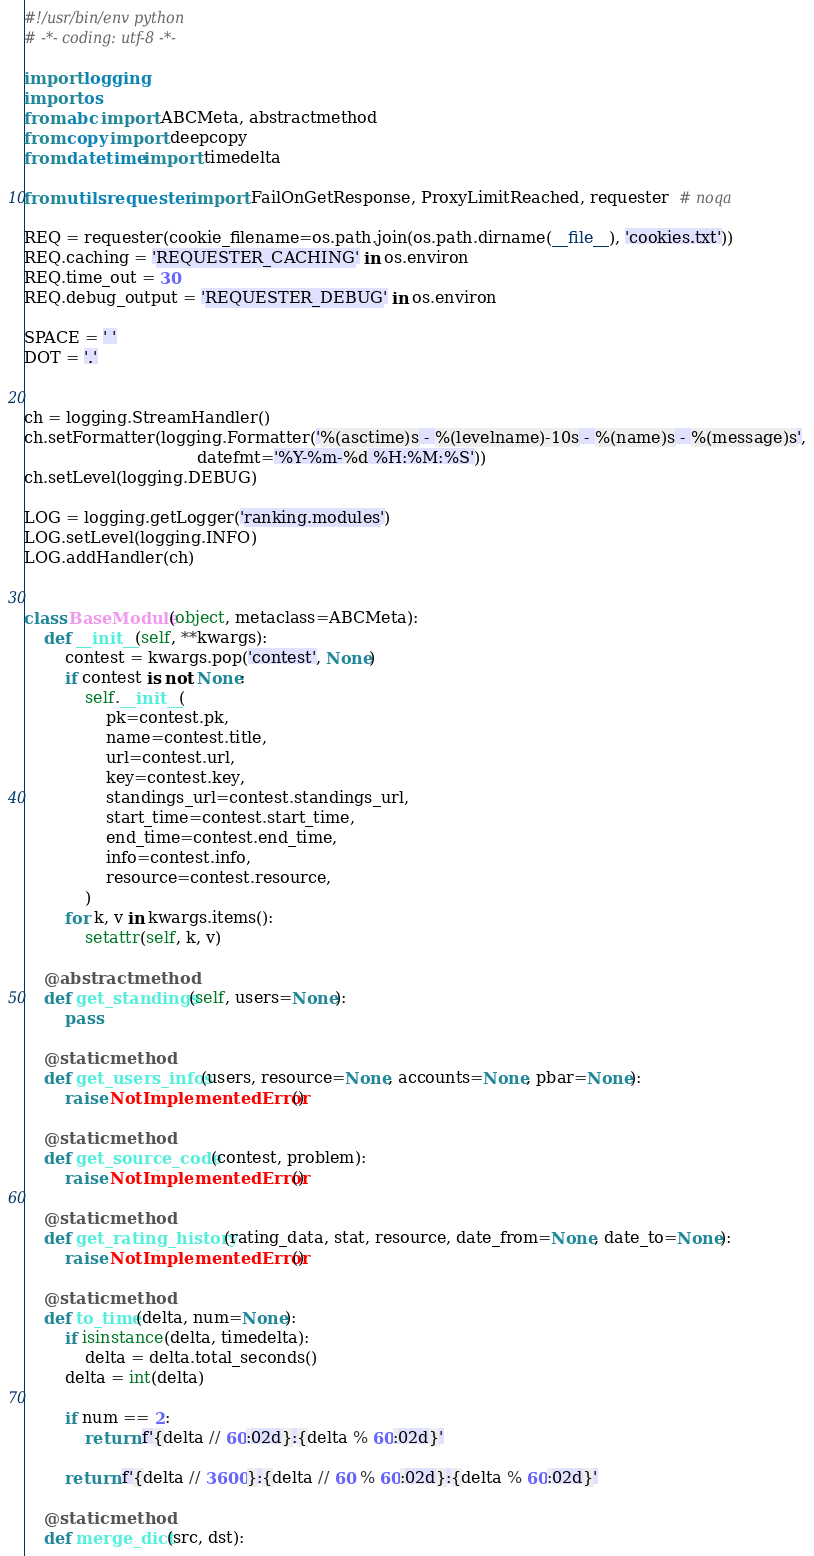Convert code to text. <code><loc_0><loc_0><loc_500><loc_500><_Python_>#!/usr/bin/env python
# -*- coding: utf-8 -*-

import logging
import os
from abc import ABCMeta, abstractmethod
from copy import deepcopy
from datetime import timedelta

from utils.requester import FailOnGetResponse, ProxyLimitReached, requester  # noqa

REQ = requester(cookie_filename=os.path.join(os.path.dirname(__file__), 'cookies.txt'))
REQ.caching = 'REQUESTER_CACHING' in os.environ
REQ.time_out = 30
REQ.debug_output = 'REQUESTER_DEBUG' in os.environ

SPACE = ' '
DOT = '.'


ch = logging.StreamHandler()
ch.setFormatter(logging.Formatter('%(asctime)s - %(levelname)-10s - %(name)s - %(message)s',
                                  datefmt='%Y-%m-%d %H:%M:%S'))
ch.setLevel(logging.DEBUG)

LOG = logging.getLogger('ranking.modules')
LOG.setLevel(logging.INFO)
LOG.addHandler(ch)


class BaseModule(object, metaclass=ABCMeta):
    def __init__(self, **kwargs):
        contest = kwargs.pop('contest', None)
        if contest is not None:
            self.__init__(
                pk=contest.pk,
                name=contest.title,
                url=contest.url,
                key=contest.key,
                standings_url=contest.standings_url,
                start_time=contest.start_time,
                end_time=contest.end_time,
                info=contest.info,
                resource=contest.resource,
            )
        for k, v in kwargs.items():
            setattr(self, k, v)

    @abstractmethod
    def get_standings(self, users=None):
        pass

    @staticmethod
    def get_users_infos(users, resource=None, accounts=None, pbar=None):
        raise NotImplementedError()

    @staticmethod
    def get_source_code(contest, problem):
        raise NotImplementedError()

    @staticmethod
    def get_rating_history(rating_data, stat, resource, date_from=None, date_to=None):
        raise NotImplementedError()

    @staticmethod
    def to_time(delta, num=None):
        if isinstance(delta, timedelta):
            delta = delta.total_seconds()
        delta = int(delta)

        if num == 2:
            return f'{delta // 60:02d}:{delta % 60:02d}'

        return f'{delta // 3600}:{delta // 60 % 60:02d}:{delta % 60:02d}'

    @staticmethod
    def merge_dict(src, dst):</code> 